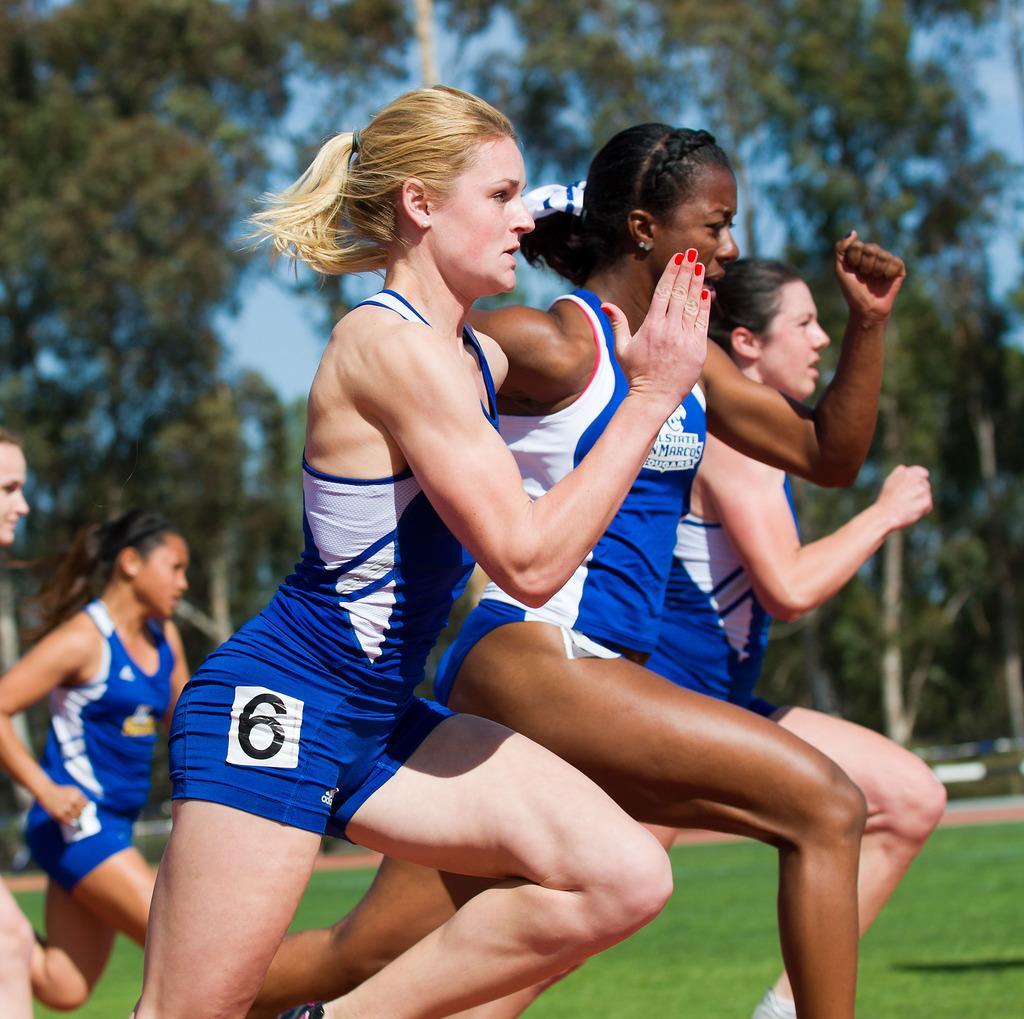In one or two sentences, can you explain what this image depicts? In this image I can see few women and I can see all of them are wearing blue colour dress. In the background I can see few trees, the sky and I can see this image is little bit blurry from background. 